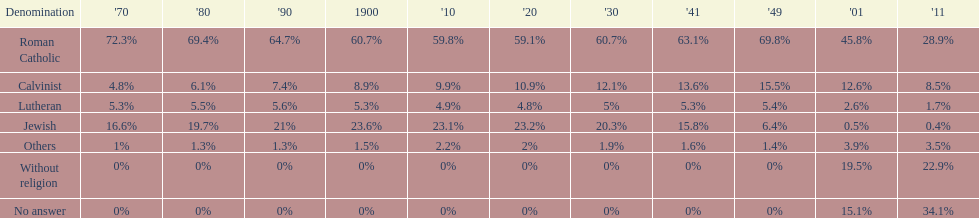How many denominations never dropped below 20%? 1. 